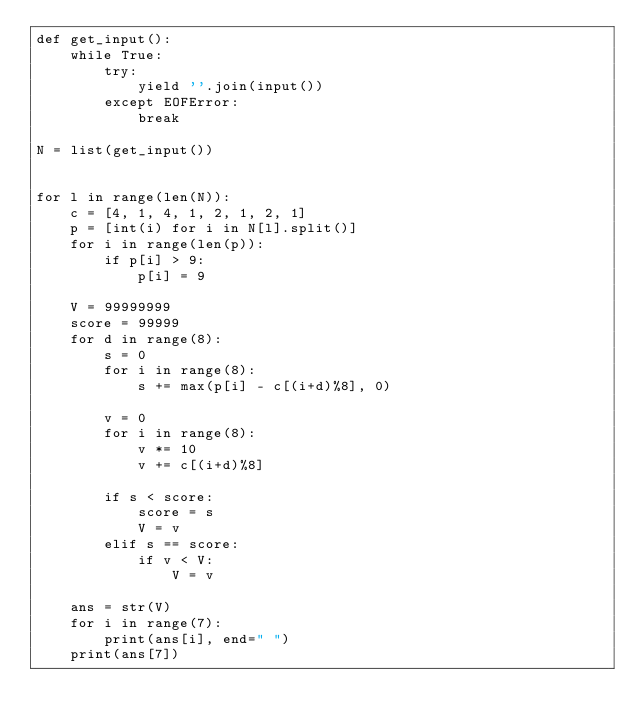Convert code to text. <code><loc_0><loc_0><loc_500><loc_500><_Python_>def get_input():
    while True:
        try:
            yield ''.join(input())
        except EOFError:
            break

N = list(get_input())


for l in range(len(N)):
    c = [4, 1, 4, 1, 2, 1, 2, 1]
    p = [int(i) for i in N[l].split()]
    for i in range(len(p)):
        if p[i] > 9:
            p[i] = 9

    V = 99999999
    score = 99999
    for d in range(8):
        s = 0
        for i in range(8):
            s += max(p[i] - c[(i+d)%8], 0)

        v = 0
        for i in range(8):
            v *= 10
            v += c[(i+d)%8]

        if s < score:
            score = s
            V = v
        elif s == score:
            if v < V:
                V = v

    ans = str(V)
    for i in range(7):
        print(ans[i], end=" ")
    print(ans[7])
</code> 